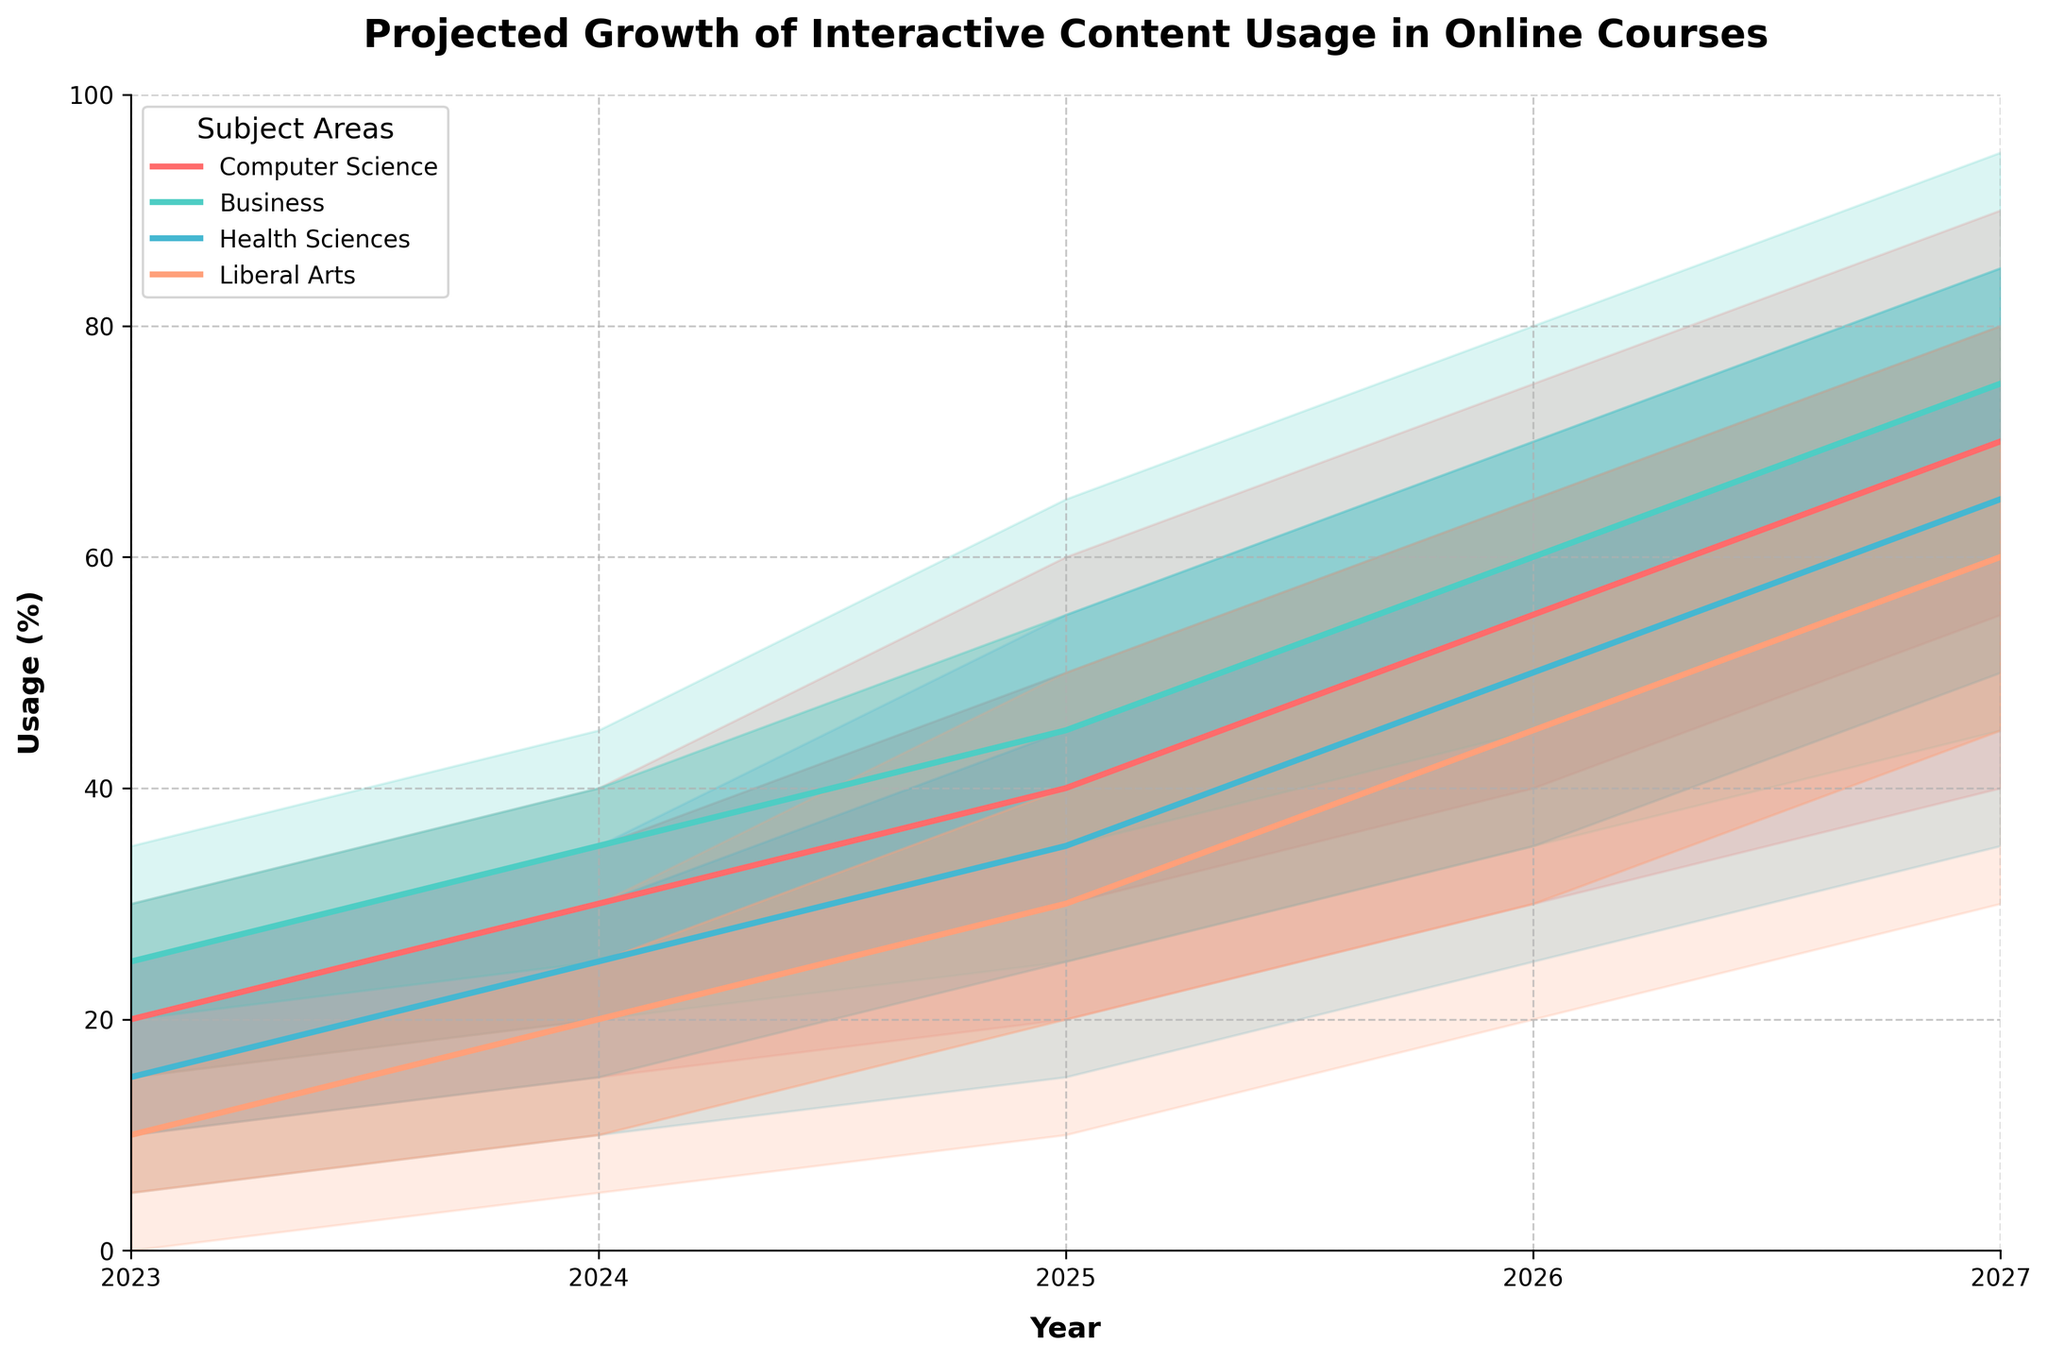What is the central estimate for Computer Science in 2025? Locate the central estimate line for Computer Science in 2025. According to the graph, it’s 40%.
Answer: 40 Which subject area has the highest upper bound in 2027? Compare the upper bounds for all subject areas in 2027. Business has the highest upper bound at 95%.
Answer: Business Between which years does Liberal Arts show the most significant increase in the central estimate? Observe the central estimate line for Liberal Arts from 2023 to 2027. The most significant increase is between 2024 and 2025, from 20% to 30%.
Answer: 2024 and 2025 In 2024, how much greater is the central estimate for Business compared to Health Sciences? Find the central estimate for Business (35%) and Health Sciences (25%) in 2024. The difference is 35% - 25% = 10%.
Answer: 10% What is the range of the high estimate for Health Sciences in 2026? Check the high estimate boundaries for Health Sciences in 2026. It spans from 50% to 60%, a range of 10%.
Answer: 10% How do the projections for Computer Science and Liberal Arts compare in 2027? Look at the estimates for both subjects in 2027. Computer Science's central estimate is 70%, with bounds from 40% to 90%. Liberal Arts' central estimate is 60%, with bounds from 30% to 80%. Computer Science is higher in both central and upper estimates.
Answer: Computer Science is higher What is the overall trend for Health Sciences from 2023 to 2027? Observe the progressive increase in central estimates for Health Sciences from 15% in 2023 to 65% in 2027. The trend is consistently upward.
Answer: Upward trend Which subject shows the most variability in its projections for 2025? Compare the widths of the projection bands for each subject in 2025. Liberal Arts has the widest band, from 10% to 50%, indicating the most variability.
Answer: Liberal Arts What is the projected change in the central estimate for Business from 2023 to 2027? The central estimate for Business in 2023 is 25%, and it increases to 75% by 2027. The change is 75% - 25% = 50%.
Answer: 50% Which subject has the narrowest band for its upper and lower bounds in 2024? The band width for each subject’s projections in 2024 should be observed. Health Sciences has the narrowest band width, from 10% to 35%.
Answer: Health Sciences 